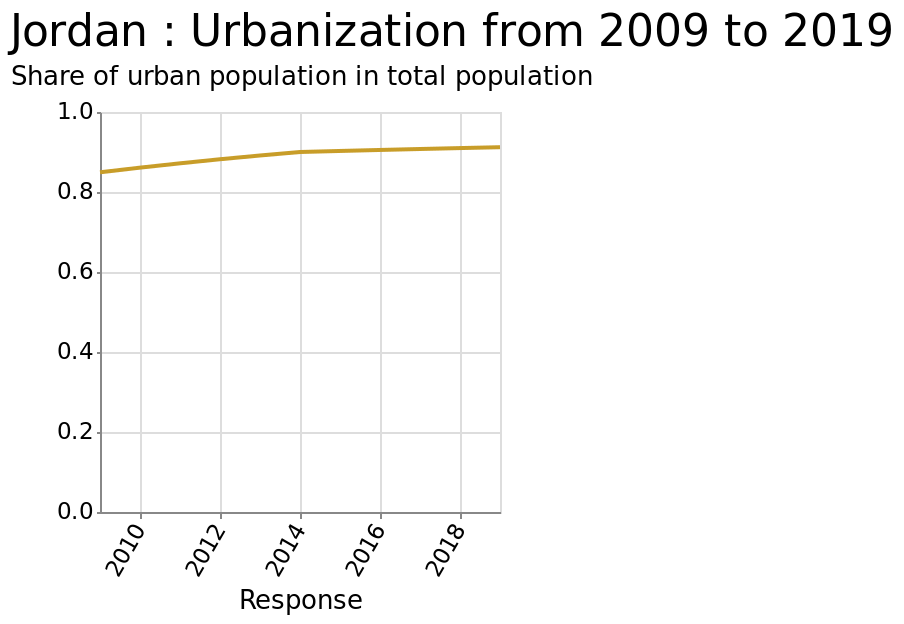<image>
Has the rate of population growth remained the same since 2014?  No, the rate of population growth has slowed since 2014. How would you describe the change in population since 2014? The population has slightly increased, but the rate of increase has reduced since 2014. 